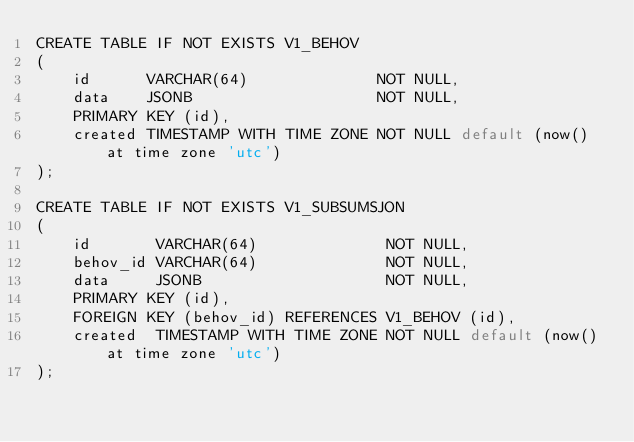Convert code to text. <code><loc_0><loc_0><loc_500><loc_500><_SQL_>CREATE TABLE IF NOT EXISTS V1_BEHOV
(
    id      VARCHAR(64)              NOT NULL,
    data    JSONB                    NOT NULL,
    PRIMARY KEY (id),
    created TIMESTAMP WITH TIME ZONE NOT NULL default (now() at time zone 'utc')
);

CREATE TABLE IF NOT EXISTS V1_SUBSUMSJON
(
    id       VARCHAR(64)              NOT NULL,
    behov_id VARCHAR(64)              NOT NULL,
    data     JSONB                    NOT NULL,
    PRIMARY KEY (id),
    FOREIGN KEY (behov_id) REFERENCES V1_BEHOV (id),
    created  TIMESTAMP WITH TIME ZONE NOT NULL default (now() at time zone 'utc')
);


</code> 